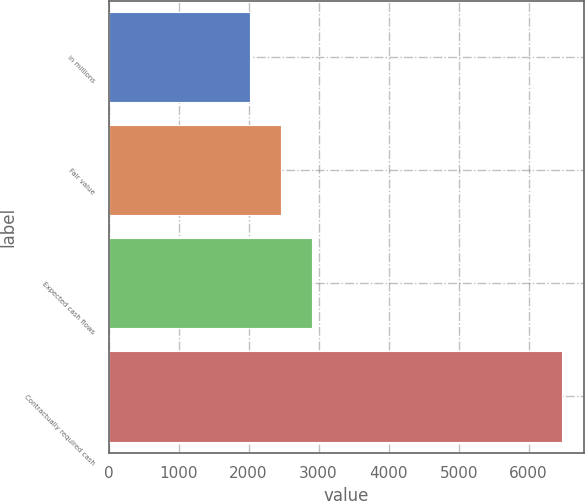Convert chart. <chart><loc_0><loc_0><loc_500><loc_500><bar_chart><fcel>in millions<fcel>Fair value<fcel>Expected cash flows<fcel>Contractually required cash<nl><fcel>2015<fcel>2460.7<fcel>2906.4<fcel>6472<nl></chart> 